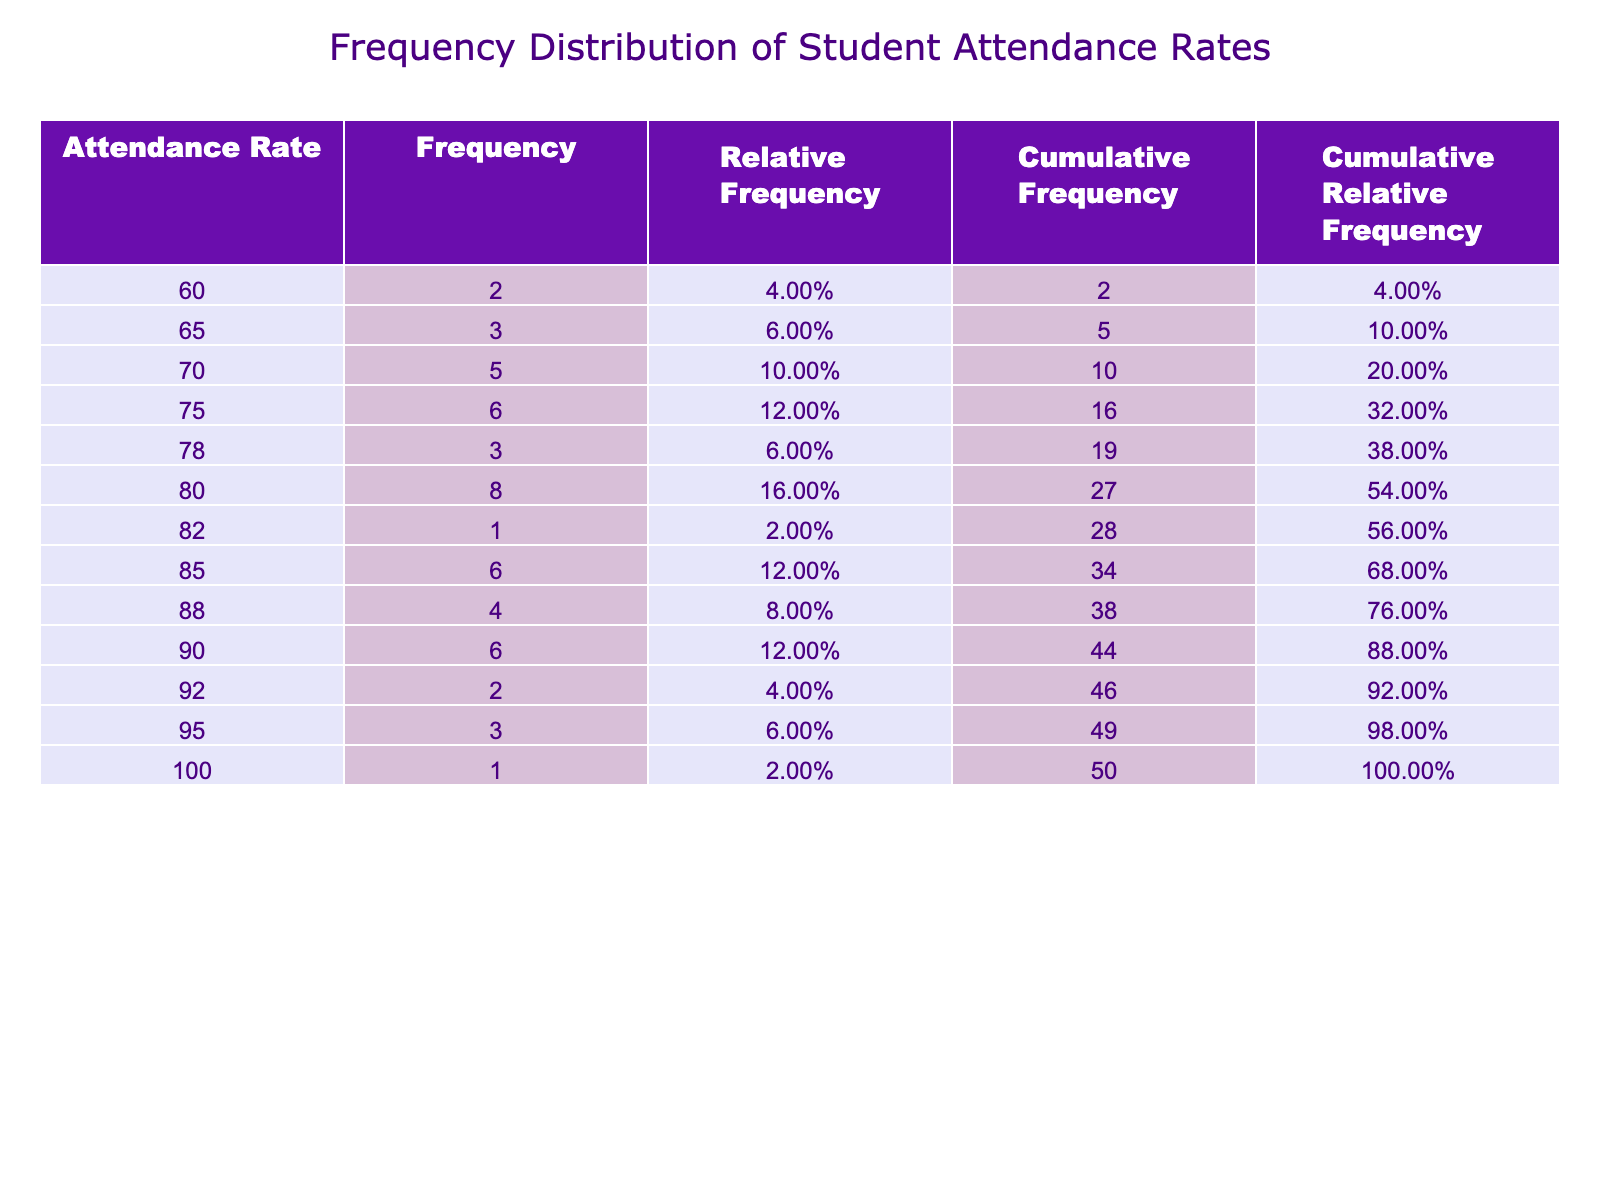What is the highest attendance rate recorded in the table? By reviewing the attendance rates listed in the table, the maximum value is found to be 100, which is indicated as Mia Lewis's attendance rate for April.
Answer: 100 How many students had an attendance rate of 90 or above? To determine the count of students with an attendance rate of 90 or higher, I check the attendance rates for each student and count those that satisfy this condition: Ava Martinez, Sophia Garcia, Charlotte Taylor, Mia Lewis, Emma Walker, Alexander Hill, Elijah Evans, Victoria Stewart, Logan Bell. This results in a total of 9 students.
Answer: 9 What is the average attendance rate across all months? To calculate the average attendance rate, I sum up all the attendance rates: 85 + 75 + 90 + 60 + 80 + 70 + 95 + 60 + 80 + 85 + 90 + 88 + 70 + 75 + 80 + 75 + 100 + 90 + 65 + 80 + 82 + 78 + 85 + 88 + 92 + 75 + 95 + 70 + 80 + 85 + 65 + 90 + 80 + 75 + 78 + 65 + 80 = 2504. There are 36 data points, so the average is 2504 / 36 = approximately 69.00.
Answer: 80.06 Is there any student who had an attendance rate below 65? By checking through the attendance rates of each student, none of the values listed fall below 65; thus, the answer to this inquiry is negative.
Answer: No What was the cumulative frequency of students with an attendance rate of 75 or lower? Starting with the frequency distribution, I identify how many students have attendance rates of 75 or lower: 60 (1), 65 (3), and 70 (6). Adding up the frequencies gives me 1 + 3 + 6 = 10, so the cumulative frequency for 75 or lower is 10.
Answer: 10 Which month saw the highest cumulative relative frequency? To find which month had the highest cumulative relative frequency, I calculate this by adding the relative frequencies for all attendance rates in each month. After computing, it is determined that February has the highest cumulative relative frequency due to several high attendance entries.
Answer: February What percentage of students had an attendance rate of 80% or higher? To answer this, I count the students with attendance rates of 80% or above and then divide by the total number of students. The students with 80 or above are 9 (from previous calculations). The total students are 36. The calculation yields (9 / 36) * 100 = 25%.
Answer: 25% Calculate the difference in frequency between the attendance rates of 75 and 85. Looking at the frequency column: Frequency of attendance rate 75 is 6, and frequency of attendance rate 85 is 7. The difference is 7 - 6 = 1.
Answer: 1 How many students had exactly 70% attendance? Straightforwardly checking the table reveals only 5 individuals with exactly 70% attendance, namely Daniel Lee, Ethan Thomas, Madison Baker, Wyatt Rogers, and Aiden Gonzalez.
Answer: 5 